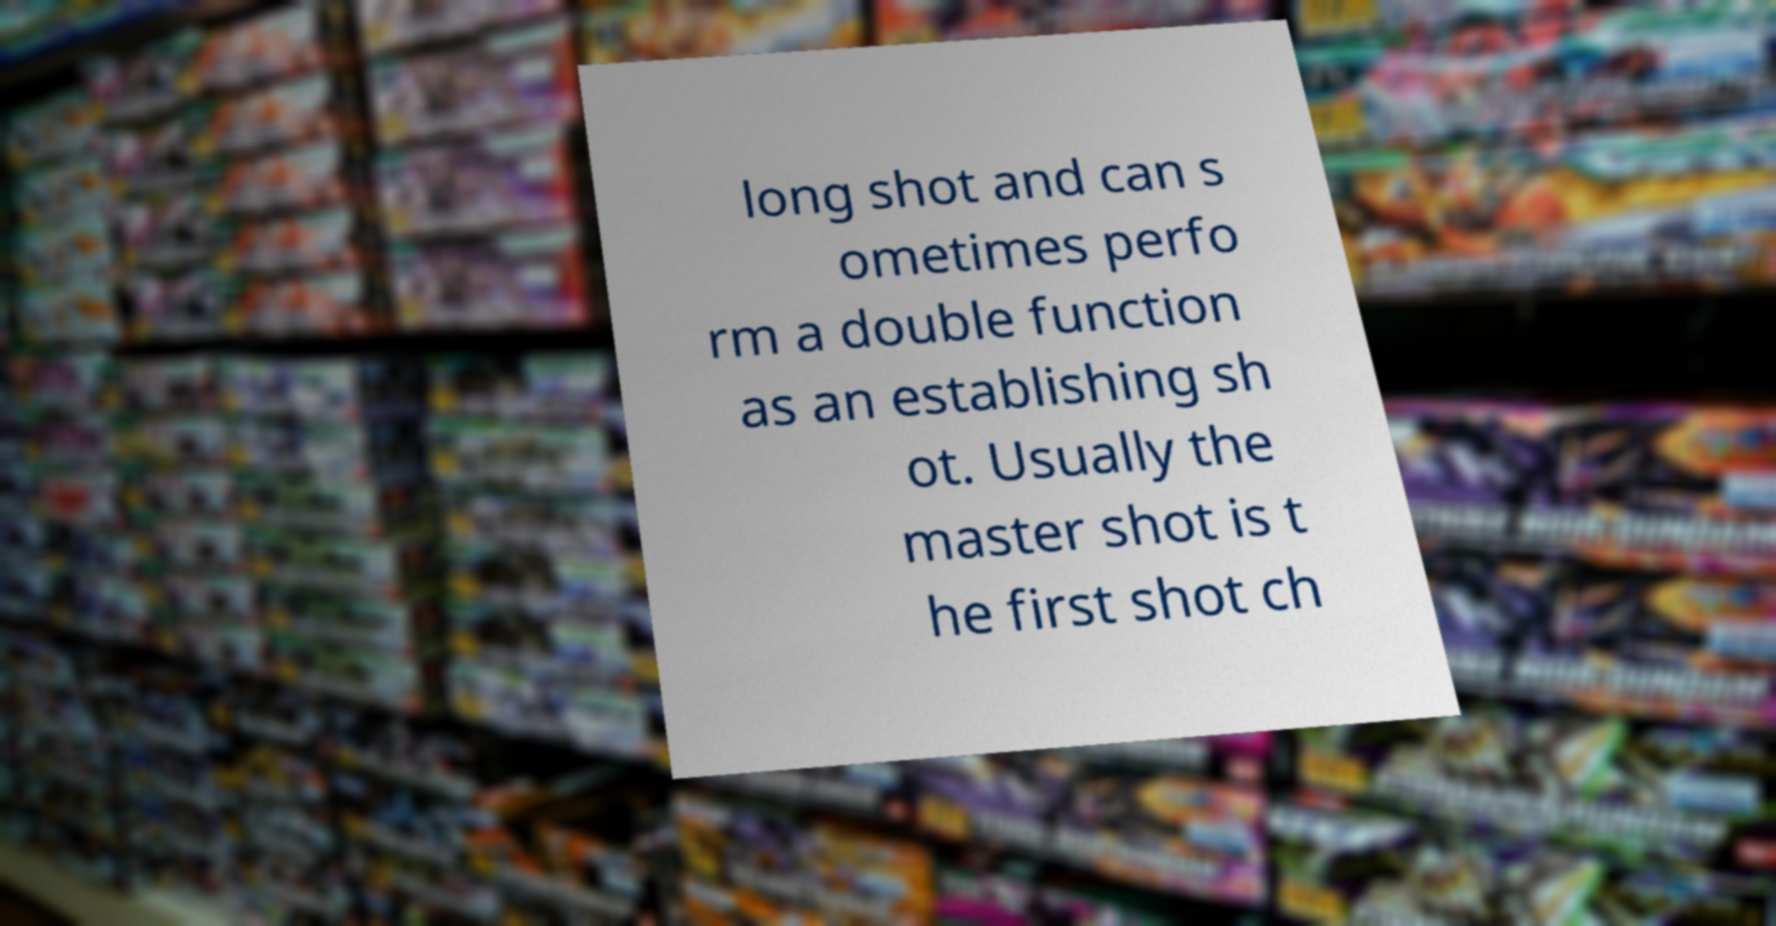Could you assist in decoding the text presented in this image and type it out clearly? long shot and can s ometimes perfo rm a double function as an establishing sh ot. Usually the master shot is t he first shot ch 